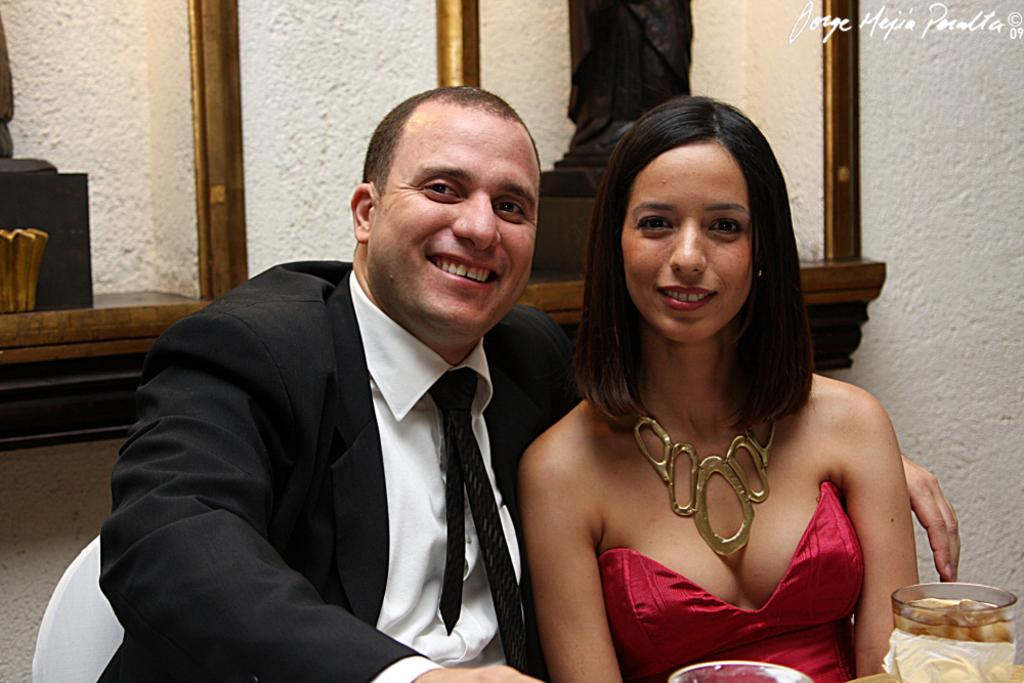What can be seen in the image related to people? There are persons wearing clothes in the image. What object is located in the bottom right of the image? There is a glass in the bottom right of the image. What type of artistic elements can be seen in the background of the image? There are sculptures in the background of the image. What type of cactus can be seen in the image? There is no cactus present in the image. Is there a fire visible in the image? There is no fire visible in the image. 